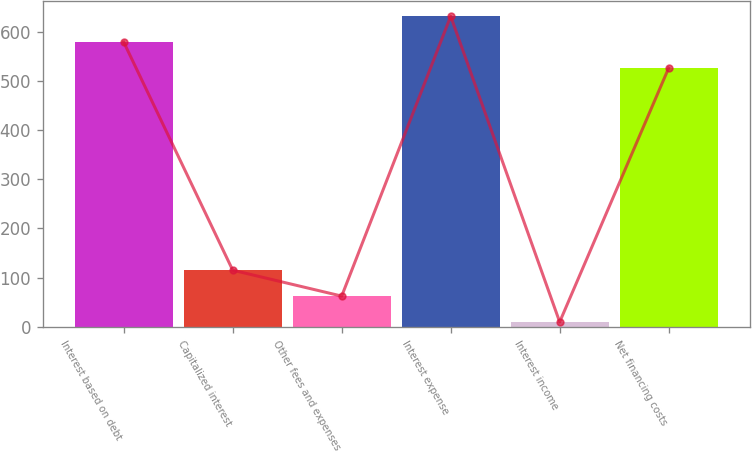Convert chart. <chart><loc_0><loc_0><loc_500><loc_500><bar_chart><fcel>Interest based on debt<fcel>Capitalized interest<fcel>Other fees and expenses<fcel>Interest expense<fcel>Interest income<fcel>Net financing costs<nl><fcel>578.6<fcel>115.2<fcel>62.6<fcel>631.2<fcel>10<fcel>526<nl></chart> 